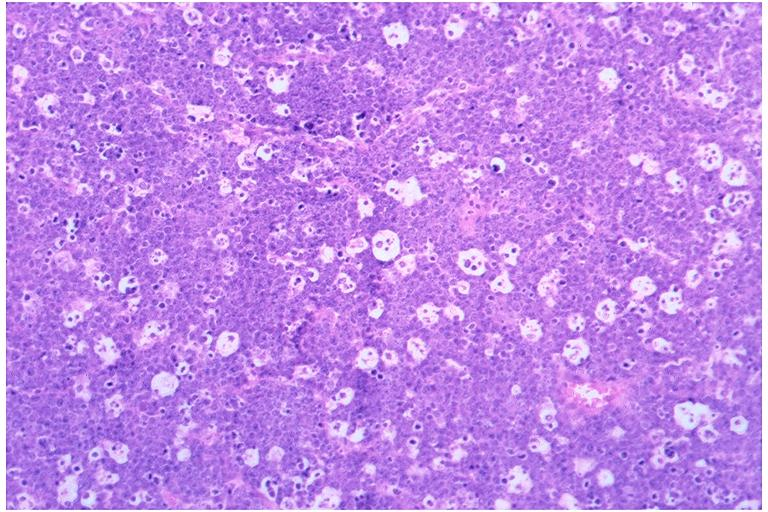s whipples disease present?
Answer the question using a single word or phrase. No 